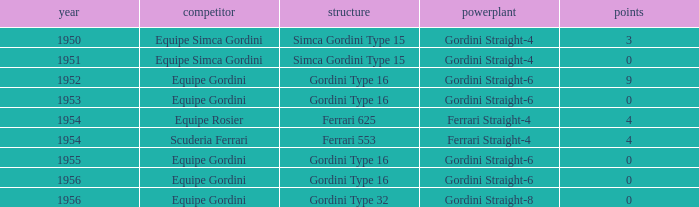How many points after 1956? 0.0. Can you parse all the data within this table? {'header': ['year', 'competitor', 'structure', 'powerplant', 'points'], 'rows': [['1950', 'Equipe Simca Gordini', 'Simca Gordini Type 15', 'Gordini Straight-4', '3'], ['1951', 'Equipe Simca Gordini', 'Simca Gordini Type 15', 'Gordini Straight-4', '0'], ['1952', 'Equipe Gordini', 'Gordini Type 16', 'Gordini Straight-6', '9'], ['1953', 'Equipe Gordini', 'Gordini Type 16', 'Gordini Straight-6', '0'], ['1954', 'Equipe Rosier', 'Ferrari 625', 'Ferrari Straight-4', '4'], ['1954', 'Scuderia Ferrari', 'Ferrari 553', 'Ferrari Straight-4', '4'], ['1955', 'Equipe Gordini', 'Gordini Type 16', 'Gordini Straight-6', '0'], ['1956', 'Equipe Gordini', 'Gordini Type 16', 'Gordini Straight-6', '0'], ['1956', 'Equipe Gordini', 'Gordini Type 32', 'Gordini Straight-8', '0']]} 